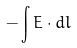<formula> <loc_0><loc_0><loc_500><loc_500>- \int E \cdot d l</formula> 